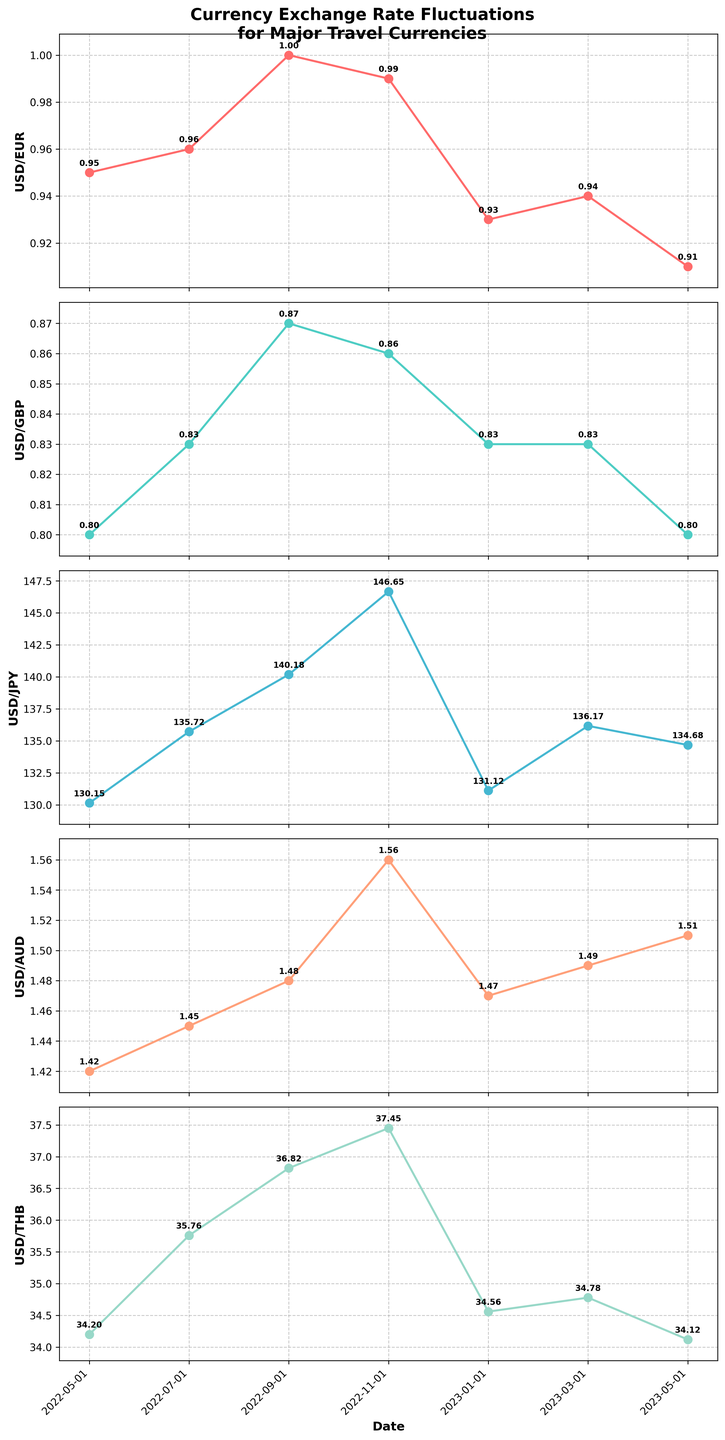What is the title of the figure? The title is typically displayed at the top of the figure. In this case, it states the main subject of the figure, which is "Currency Exchange Rate Fluctuations for Major Travel Currencies."
Answer: Currency Exchange Rate Fluctuations for Major Travel Currencies How many subplots are included in this figure? The figure contains vertical subplots, each representing a different currency pair. By counting them, we can see there are five subplots.
Answer: 5 Which currency pair has the maximum exchange rate value within the period shown? By looking at the data points in each subplot, we notice that the USD/JPY exchange rate subplot reaches the highest value of 146.65 in November 2022.
Answer: USD/JPY What is the average exchange rate of USD/EUR over the specified dates? To calculate the average, sum the USD/EUR exchange rates and divide by the number of data points. (0.95 + 0.96 + 1.00 + 0.99 + 0.93 + 0.94 + 0.91) / 7 = 6.68 / 7 = 0.9543
Answer: 0.95 Which currency pairs show a decreasing trend from the first to the last data point? By examining the overall trend from May 2022 to May 2023, we observe whether each currency pair's values decrease. USD/EUR and USD/GBP demonstrate a declining trend.
Answer: USD/EUR, USD/GBP What is the difference in the USD/JPY exchange rate between November 2022 and January 2023? Subtract the USD/JPY value in January 2023 from that in November 2022: 146.65 - 131.12 = 15.53
Answer: 15.53 During which month did USD/AUD reach its peak value? By examining the data points for USD/AUD, the highest value of 1.56 occurs in November 2022.
Answer: November 2022 Which currency pair has the most stable exchange rate over the period? Stability can be interpreted as having the smallest fluctuation range. By inspecting each subplot, USD/GBP remains between 0.80 and 0.87, making it the most stable.
Answer: USD/GBP Identify the currency pair with the lowest value in the month of January 2023. Comparing the currency pairs' values in January 2023, USD/EUR has the lowest rate at 0.93.
Answer: USD/EUR 